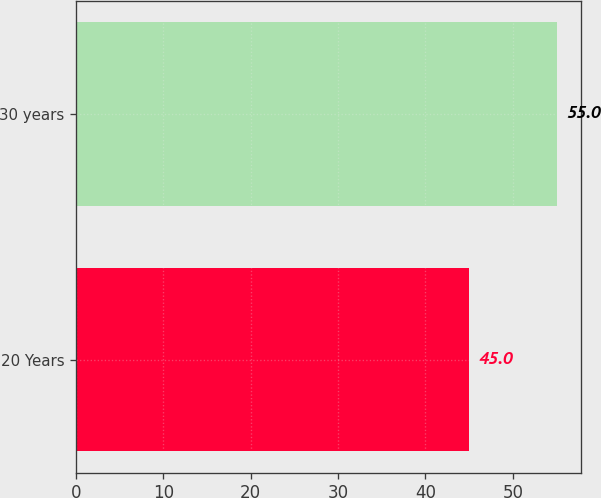<chart> <loc_0><loc_0><loc_500><loc_500><bar_chart><fcel>20 Years<fcel>30 years<nl><fcel>45<fcel>55<nl></chart> 